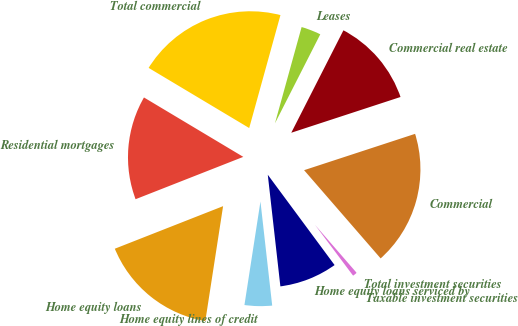<chart> <loc_0><loc_0><loc_500><loc_500><pie_chart><fcel>Taxable investment securities<fcel>Total investment securities<fcel>Commercial<fcel>Commercial real estate<fcel>Leases<fcel>Total commercial<fcel>Residential mortgages<fcel>Home equity loans<fcel>Home equity lines of credit<fcel>Home equity loans serviced by<nl><fcel>0.1%<fcel>1.14%<fcel>18.66%<fcel>12.47%<fcel>3.2%<fcel>20.72%<fcel>14.54%<fcel>16.6%<fcel>4.23%<fcel>8.35%<nl></chart> 